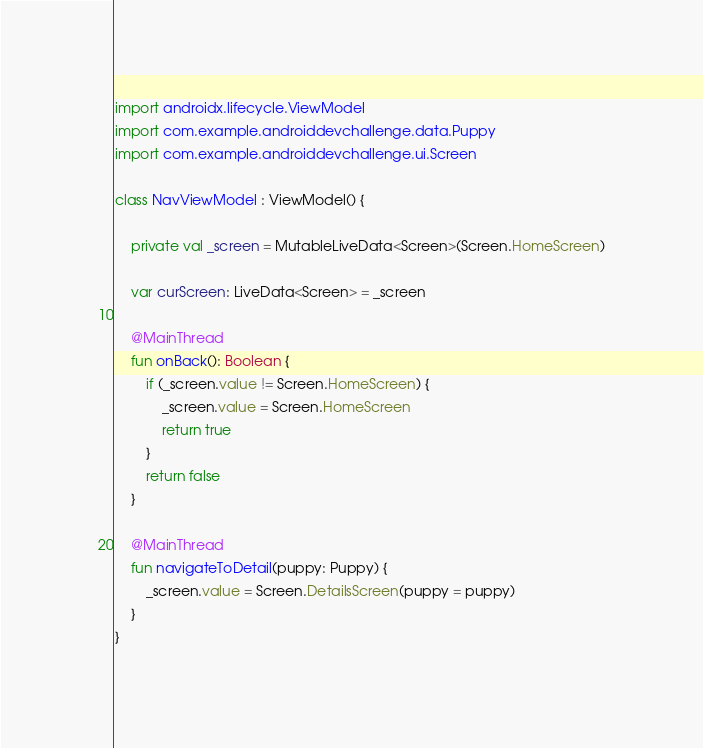Convert code to text. <code><loc_0><loc_0><loc_500><loc_500><_Kotlin_>import androidx.lifecycle.ViewModel
import com.example.androiddevchallenge.data.Puppy
import com.example.androiddevchallenge.ui.Screen

class NavViewModel : ViewModel() {

    private val _screen = MutableLiveData<Screen>(Screen.HomeScreen)

    var curScreen: LiveData<Screen> = _screen

    @MainThread
    fun onBack(): Boolean {
        if (_screen.value != Screen.HomeScreen) {
            _screen.value = Screen.HomeScreen
            return true
        }
        return false
    }

    @MainThread
    fun navigateToDetail(puppy: Puppy) {
        _screen.value = Screen.DetailsScreen(puppy = puppy)
    }
}</code> 